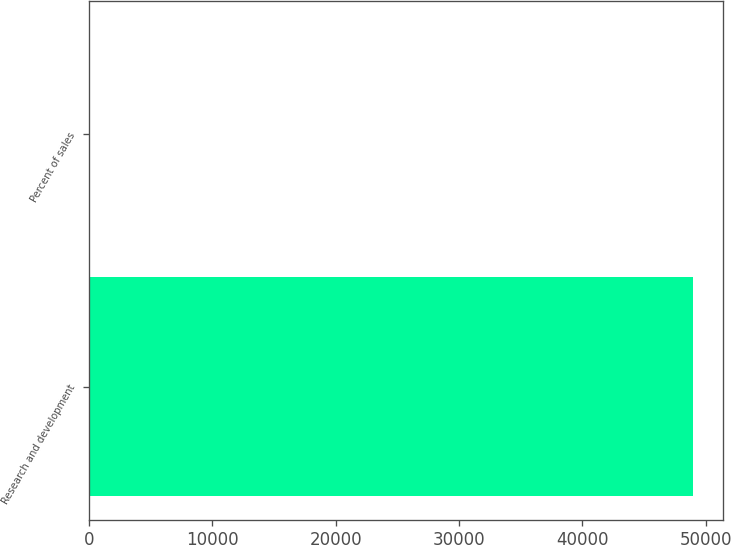Convert chart. <chart><loc_0><loc_0><loc_500><loc_500><bar_chart><fcel>Research and development<fcel>Percent of sales<nl><fcel>48959<fcel>6.4<nl></chart> 